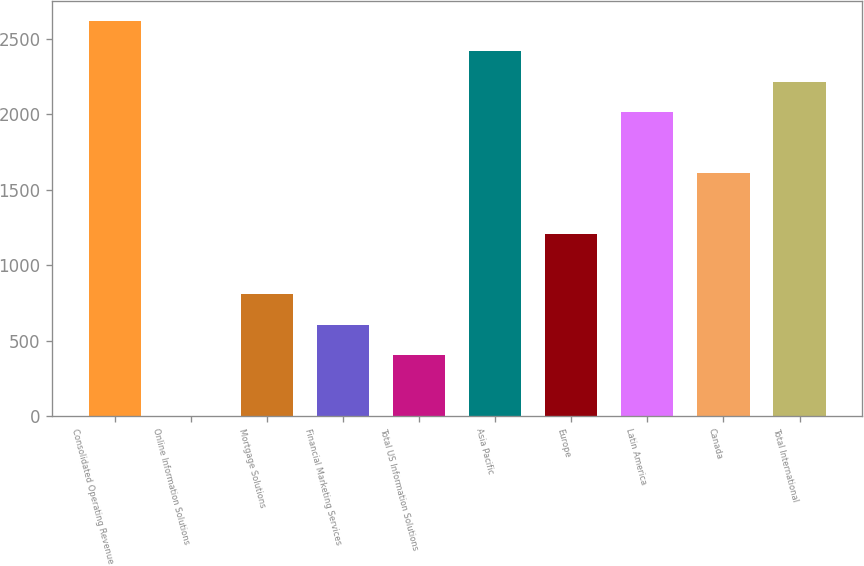Convert chart. <chart><loc_0><loc_0><loc_500><loc_500><bar_chart><fcel>Consolidated Operating Revenue<fcel>Online Information Solutions<fcel>Mortgage Solutions<fcel>Financial Marketing Services<fcel>Total US Information Solutions<fcel>Asia Pacific<fcel>Europe<fcel>Latin America<fcel>Canada<fcel>Total International<nl><fcel>2620.5<fcel>1<fcel>807<fcel>605.5<fcel>404<fcel>2419<fcel>1210<fcel>2016<fcel>1613<fcel>2217.5<nl></chart> 